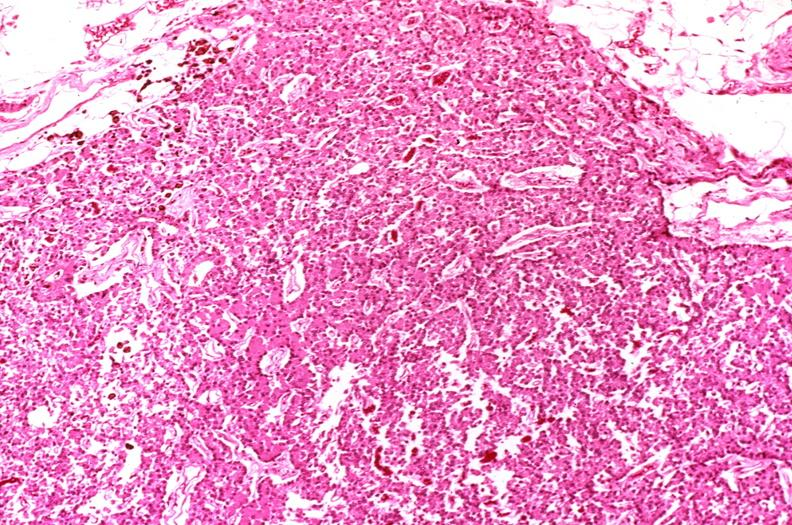does this image show parathyroid, hyperplasia?
Answer the question using a single word or phrase. Yes 